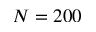<formula> <loc_0><loc_0><loc_500><loc_500>N = 2 0 0</formula> 